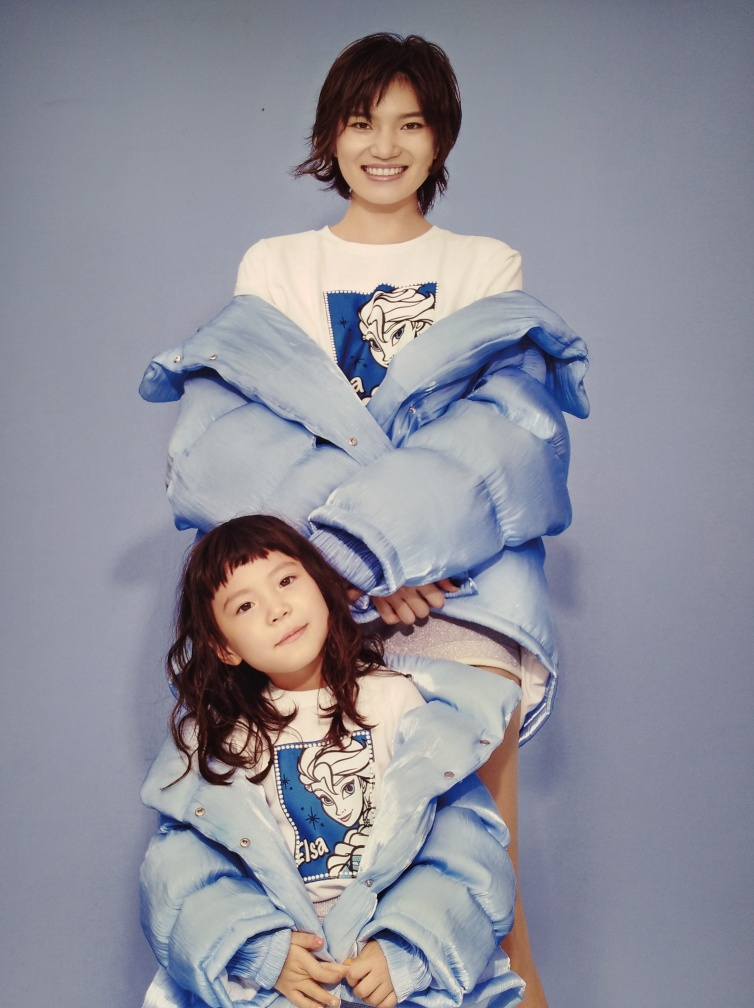What can be said about the clarity of this image? The image is quite clear, capturing crisp details in the subjects' features and attire, with no perceptible blurring or hazy areas that would detract from the overall visual quality. The background is smooth with a uniform color that accentuates the subjects, adding to the image's striking clarity. 